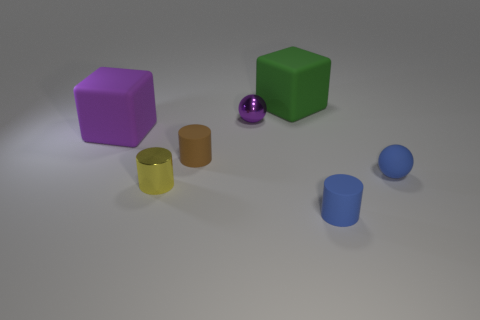Is there anything else that is the same color as the rubber ball?
Your answer should be very brief. Yes. Is the brown thing made of the same material as the tiny ball right of the tiny blue matte cylinder?
Provide a short and direct response. Yes. There is a tiny brown thing that is the same shape as the small yellow metal thing; what is it made of?
Offer a very short reply. Rubber. Are there any other things that are the same material as the green cube?
Your answer should be compact. Yes. Do the purple thing that is right of the big purple rubber object and the tiny cylinder behind the blue ball have the same material?
Your response must be concise. No. There is a ball behind the blue thing that is to the right of the tiny matte object in front of the tiny blue sphere; what is its color?
Keep it short and to the point. Purple. How many other things are the same shape as the tiny yellow metallic thing?
Keep it short and to the point. 2. Is the color of the metal cylinder the same as the small rubber sphere?
Provide a short and direct response. No. How many things are either small metal things or tiny objects that are behind the yellow thing?
Offer a very short reply. 4. Is there another metallic cylinder of the same size as the blue cylinder?
Your answer should be very brief. Yes. 